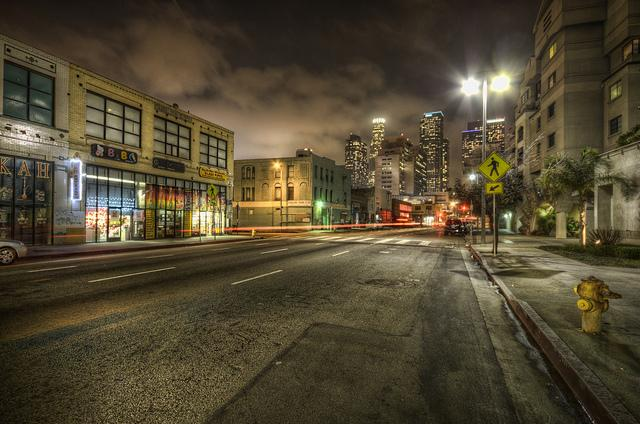What animal would you be most unlikely to see in this setting?

Choices:
A) tiger
B) dog
C) horse
D) cat tiger 